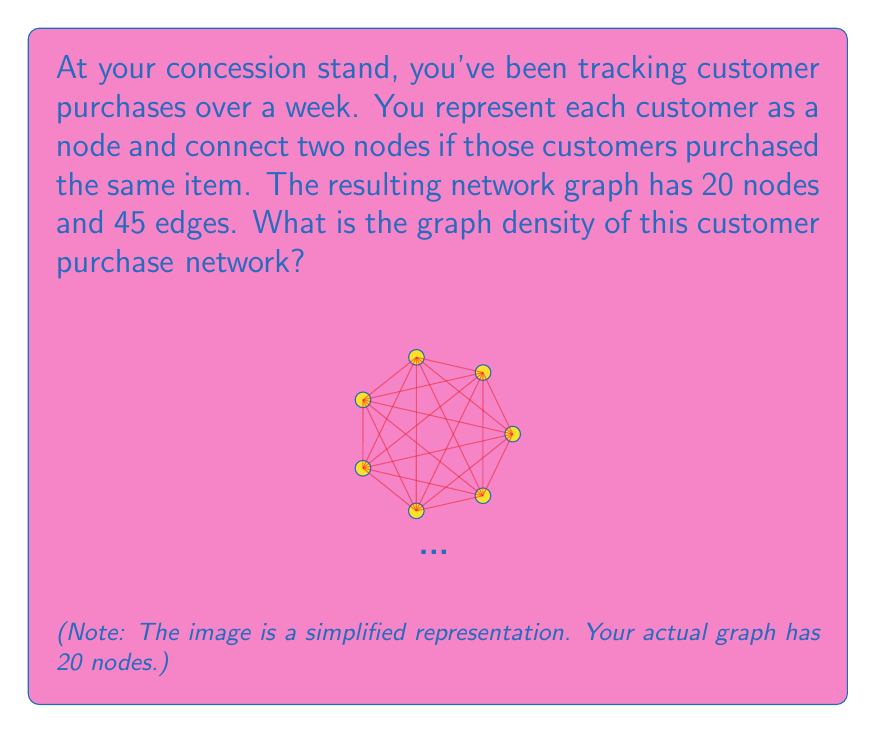Help me with this question. To solve this problem, we need to follow these steps:

1) Recall the formula for graph density in an undirected graph:

   $$D = \frac{2|E|}{|V|(|V|-1)}$$

   Where $D$ is the density, $|E|$ is the number of edges, and $|V|$ is the number of vertices (nodes).

2) We are given:
   - Number of nodes $|V| = 20$
   - Number of edges $|E| = 45$

3) Substitute these values into the formula:

   $$D = \frac{2 \cdot 45}{20 \cdot (20-1)} = \frac{90}{20 \cdot 19}$$

4) Simplify:
   $$D = \frac{90}{380} = \frac{9}{38} \approx 0.2368$$

5) The graph density is always a value between 0 and 1, where 0 indicates no connections and 1 indicates a complete graph. This value suggests a moderately connected network of customers.
Answer: $\frac{9}{38}$ or approximately 0.2368 